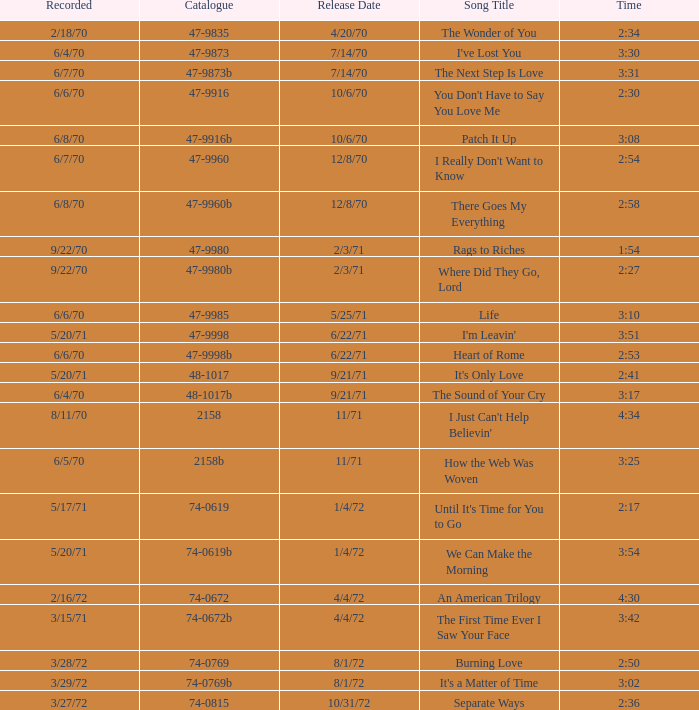What is the catalogue number for the song that is 3:17 and was released 9/21/71? 48-1017b. 